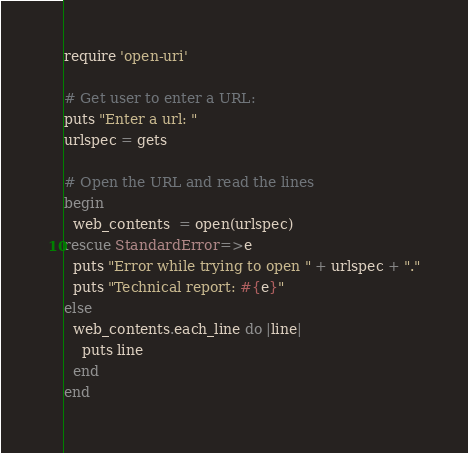Convert code to text. <code><loc_0><loc_0><loc_500><loc_500><_Ruby_>require 'open-uri'

# Get user to enter a URL:
puts "Enter a url: "
urlspec = gets

# Open the URL and read the lines
begin
  web_contents  = open(urlspec)
rescue StandardError=>e
  puts "Error while trying to open " + urlspec + "."
  puts "Technical report: #{e}"
else
  web_contents.each_line do |line|
    puts line
  end 
end
</code> 